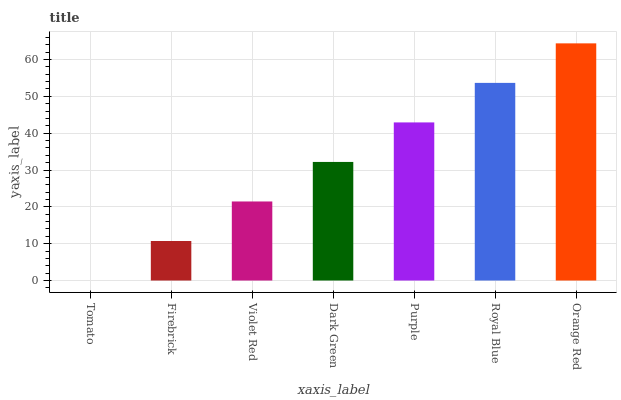Is Tomato the minimum?
Answer yes or no. Yes. Is Orange Red the maximum?
Answer yes or no. Yes. Is Firebrick the minimum?
Answer yes or no. No. Is Firebrick the maximum?
Answer yes or no. No. Is Firebrick greater than Tomato?
Answer yes or no. Yes. Is Tomato less than Firebrick?
Answer yes or no. Yes. Is Tomato greater than Firebrick?
Answer yes or no. No. Is Firebrick less than Tomato?
Answer yes or no. No. Is Dark Green the high median?
Answer yes or no. Yes. Is Dark Green the low median?
Answer yes or no. Yes. Is Royal Blue the high median?
Answer yes or no. No. Is Purple the low median?
Answer yes or no. No. 